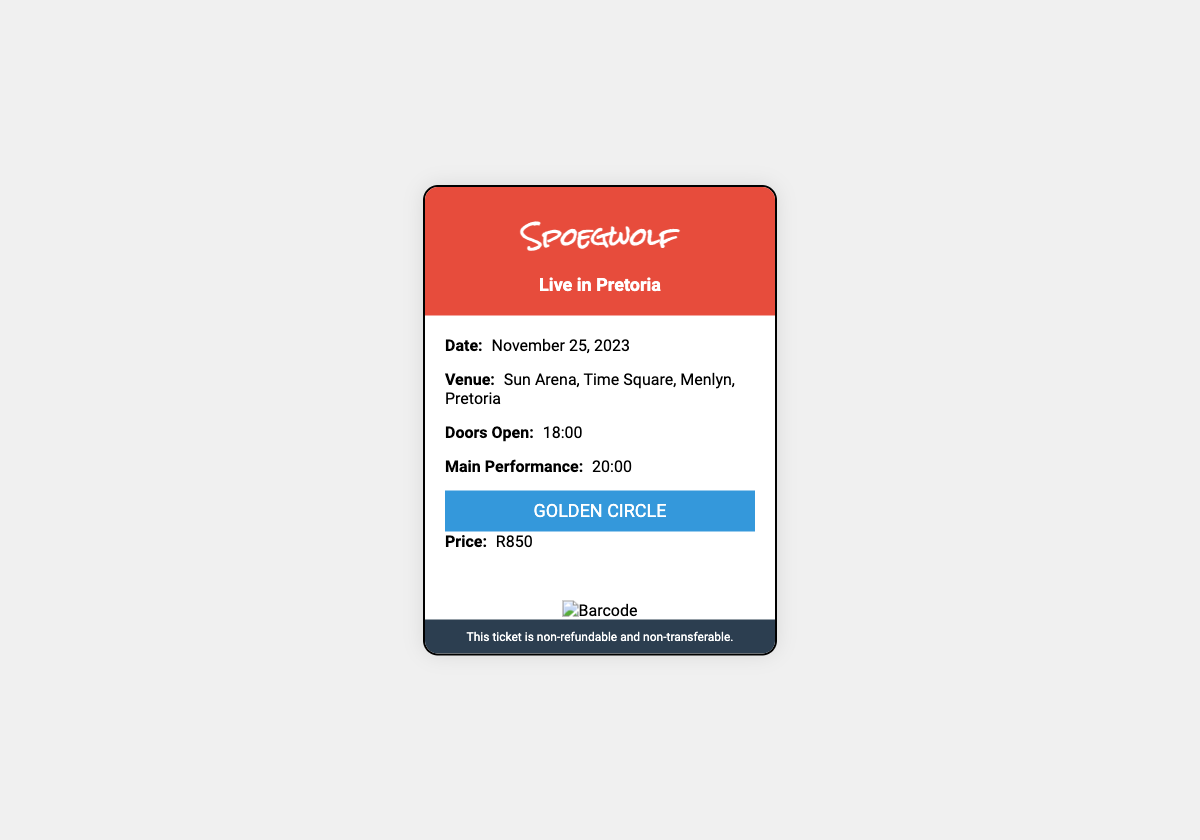What is the date of the concert? The date is mentioned in the ticket information as November 25, 2023.
Answer: November 25, 2023 What venue will host the performance? The ticket specifies that the venue is Sun Arena, Time Square, Menlyn, Pretoria.
Answer: Sun Arena, Time Square, Menlyn, Pretoria What time do the doors open? The ticket indicates that the doors will open at 18:00 as per the ticket information.
Answer: 18:00 What is the price of the Golden Circle ticket? The ticket shows that the price of the Golden Circle is R850.
Answer: R850 What time does the main performance start? The main performance time is listed as 20:00 in the ticket information.
Answer: 20:00 Is this ticket transferable? The footer of the ticket states that the ticket is non-transferable.
Answer: Non-transferable What kind of music will Spoegwolf perform? The document indicates that the concert is by Spoegwolf, known for their Afrikaans music.
Answer: Afrikaans music What does the background color of the ticket's header indicate? The ticket's header is colored red, which often signifies importance or excitement for the event.
Answer: Importance or excitement What feature is present on the ticket for entry verification? The ticket includes a barcode for entry verification purposes.
Answer: Barcode 